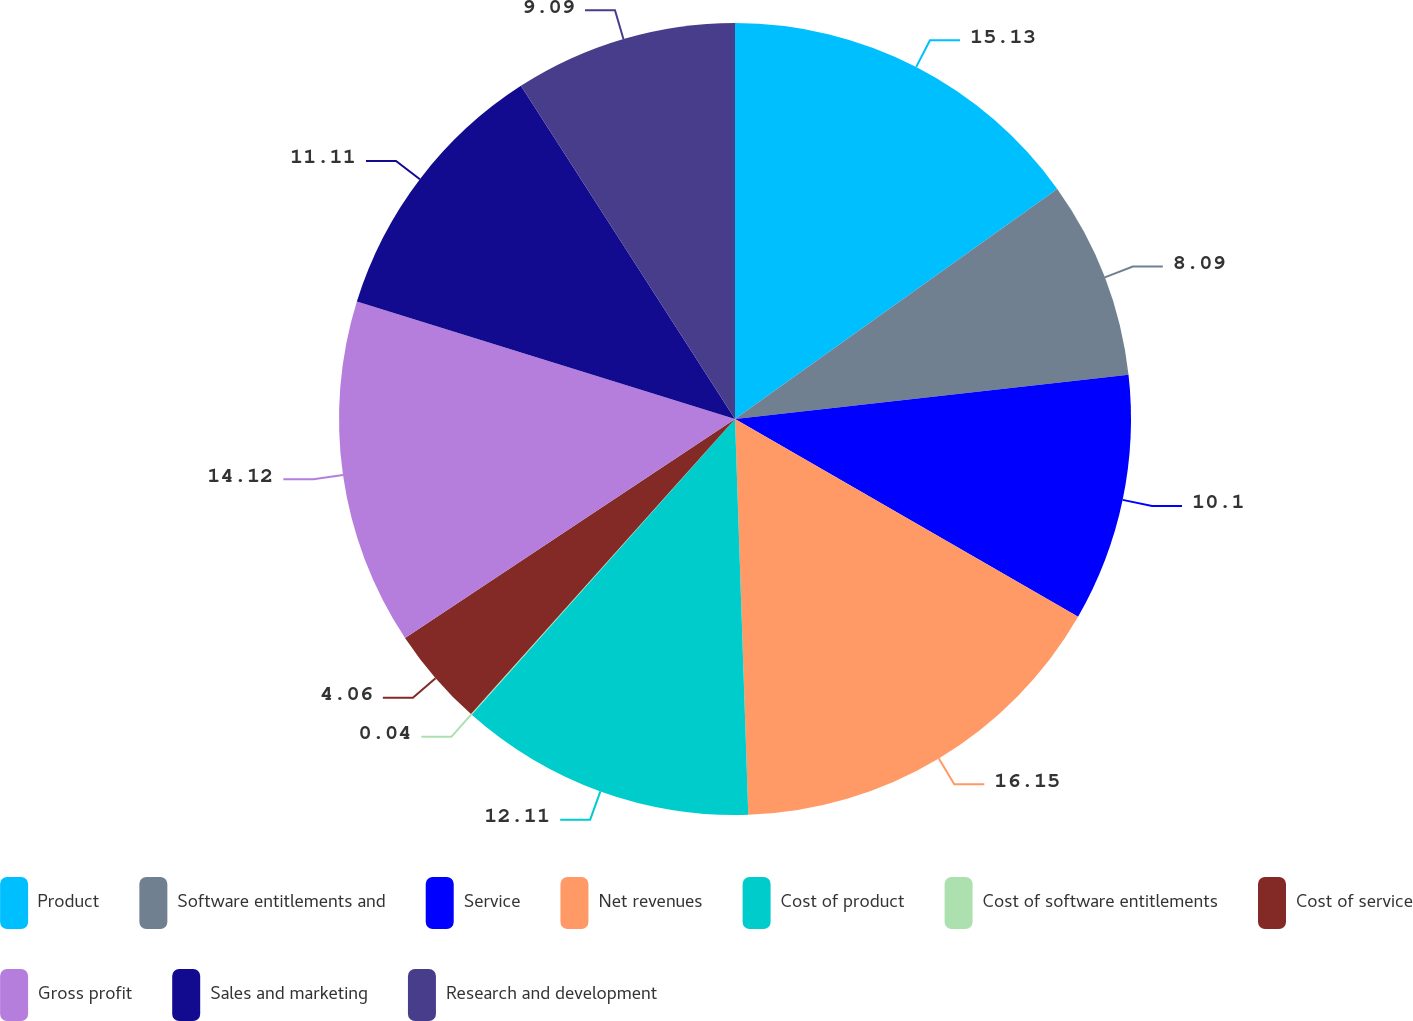<chart> <loc_0><loc_0><loc_500><loc_500><pie_chart><fcel>Product<fcel>Software entitlements and<fcel>Service<fcel>Net revenues<fcel>Cost of product<fcel>Cost of software entitlements<fcel>Cost of service<fcel>Gross profit<fcel>Sales and marketing<fcel>Research and development<nl><fcel>15.13%<fcel>8.09%<fcel>10.1%<fcel>16.14%<fcel>12.11%<fcel>0.04%<fcel>4.06%<fcel>14.12%<fcel>11.11%<fcel>9.09%<nl></chart> 